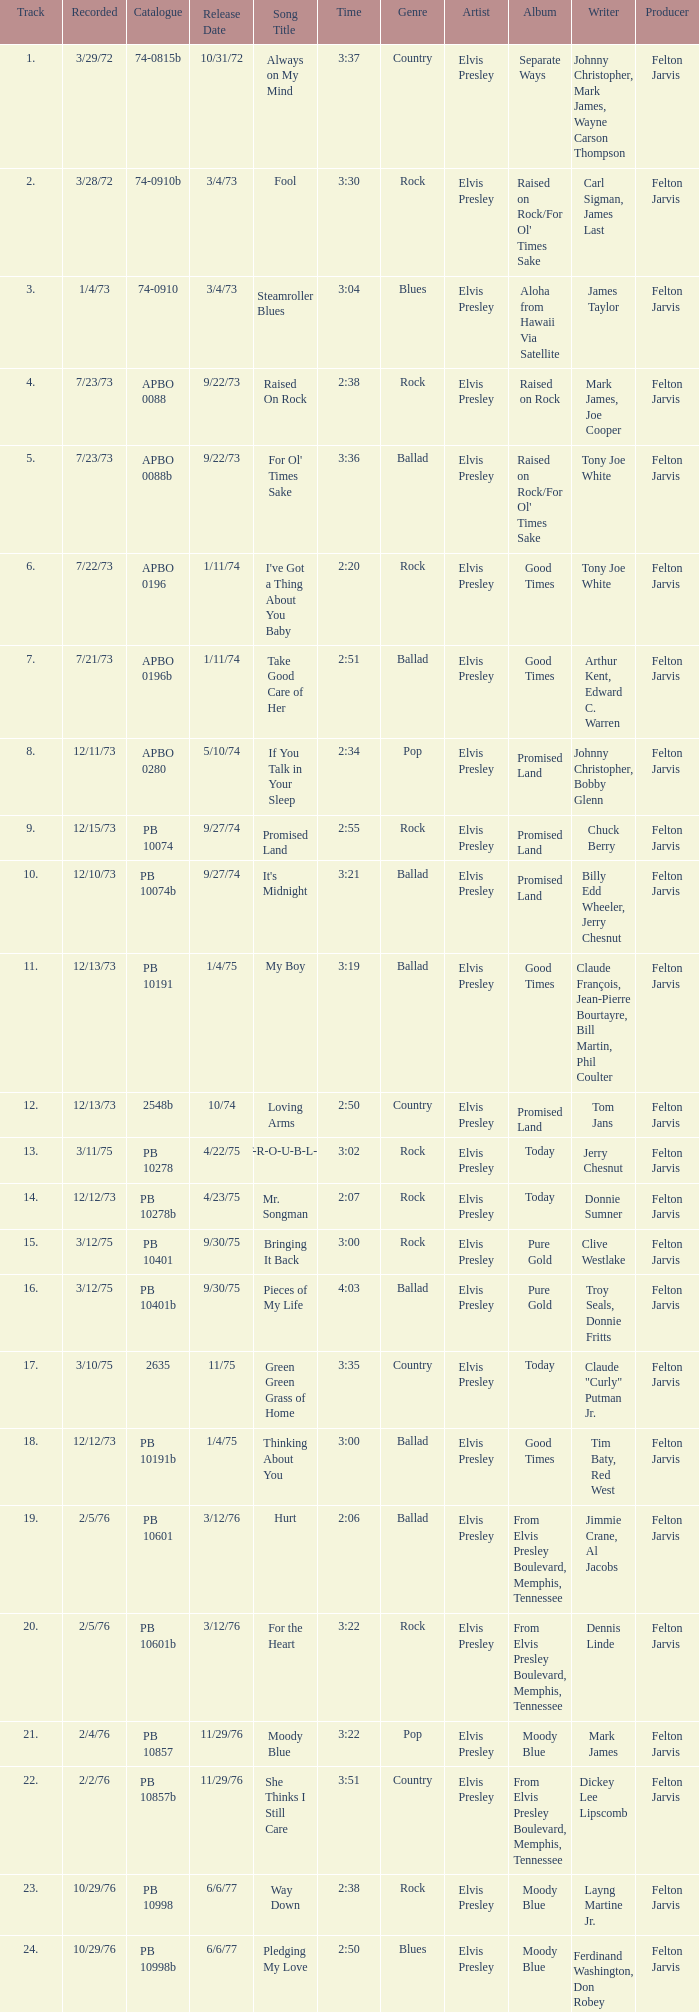What is the track with the catalog number apbo 0280? 8.0. 